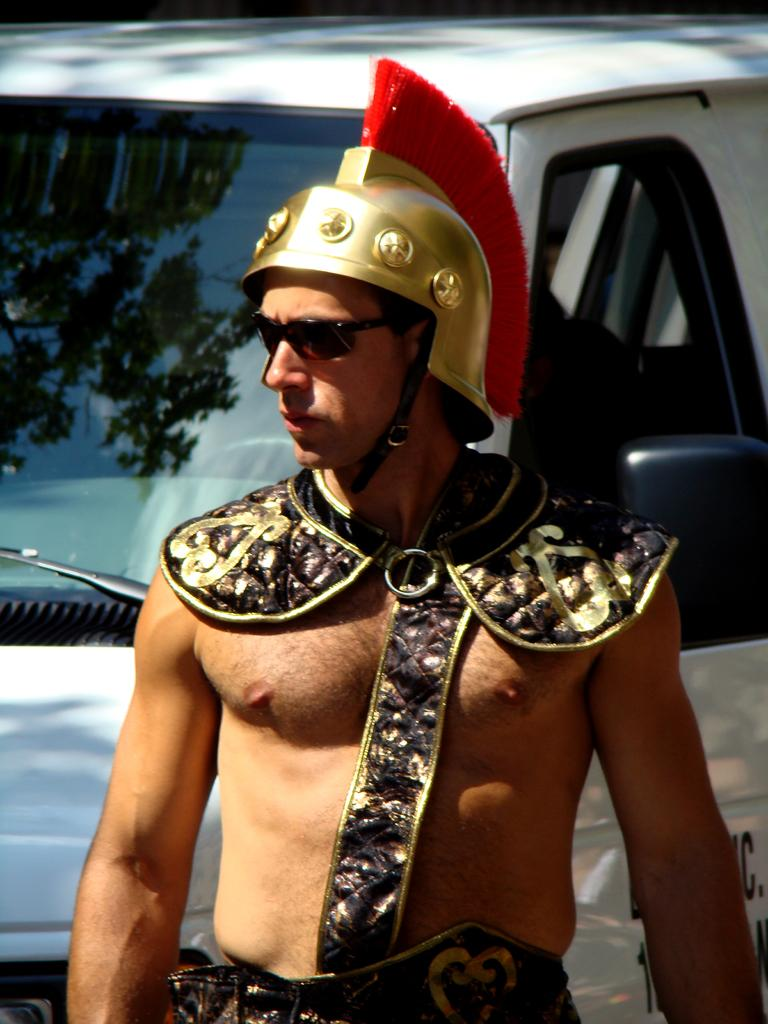Who is present in the image? There is a man in the picture. What is the man doing in the image? The man is standing. What accessories is the man wearing in the image? The man is wearing a helmet and sunglasses. What can be seen in the background of the image? There is a vehicle visible in the background of the image. What type of arch can be seen in the image? There is no arch present in the image. Can you hear the man whistling in the image? The image is silent, and there is no indication that the man is whistling. 